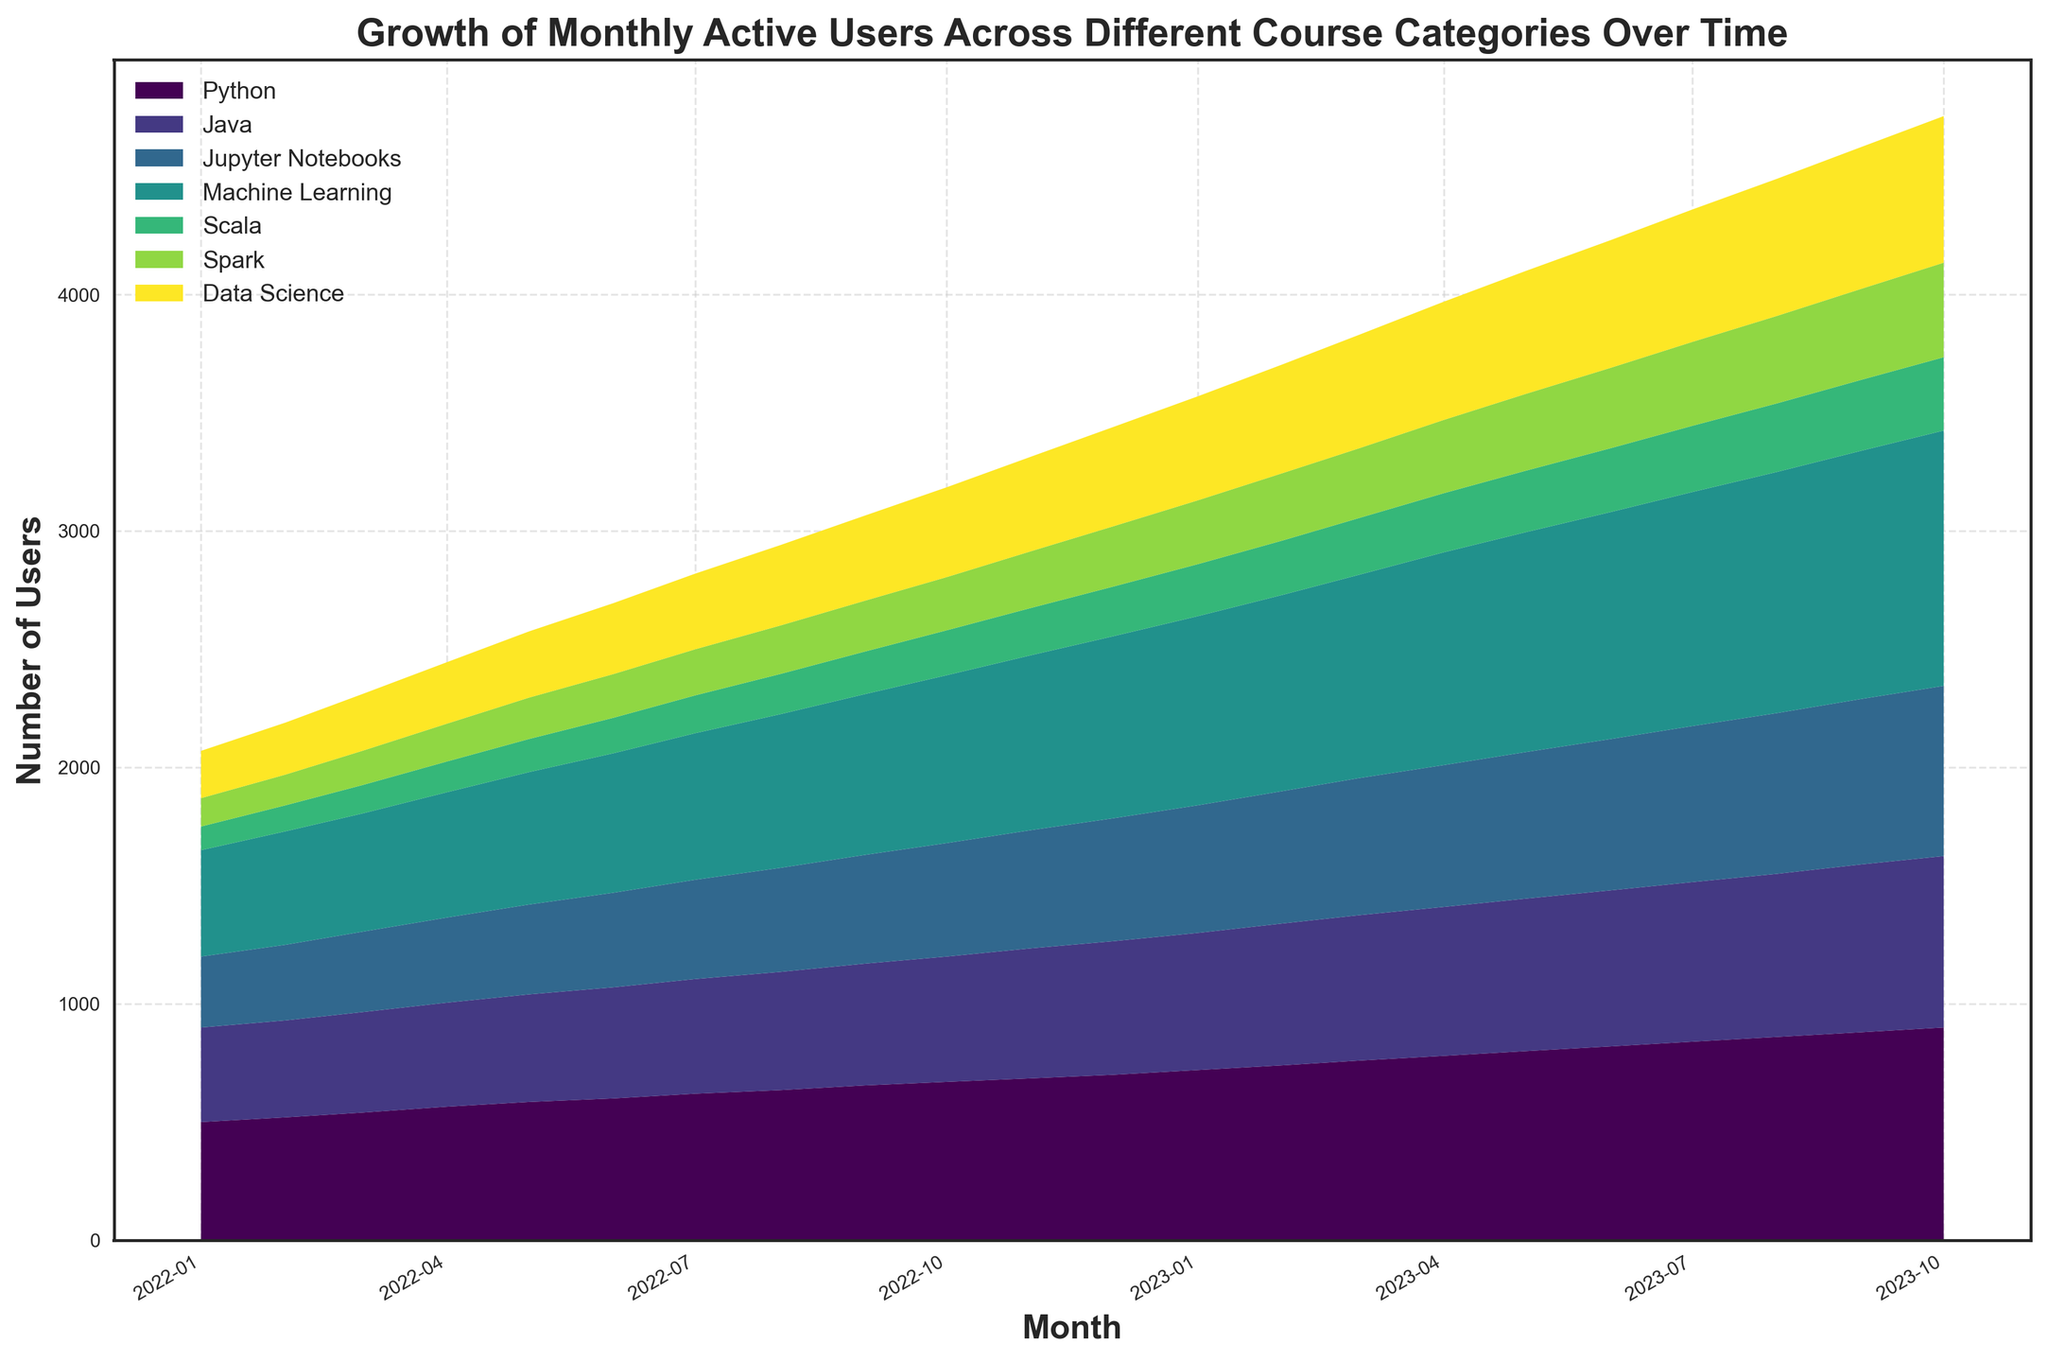What's the overall trend of active users in the Machine Learning category over time? To answer this, observe the area representing "Machine Learning." It consistently grows over time, indicating a steady increase in active users.
Answer: Steady increase Which category experienced the highest growth in monthly active users from January 2022 to October 2023? Look at the areas and their growth. "Machine Learning" has the steepest upward slope, indicating the highest growth in active users.
Answer: Machine Learning How do the user numbers for Scala and Spark compare in July 2023? Check the heights of the "Scala" and "Spark" areas in July 2023. Scala has fewer users than Spark.
Answer: Spark has more users than Scala By what factor did the number of active users in the Scala category multiply from January 2022 to October 2023? The number grew from 100 in January 2022 to 310 in October 2023. Divide 310 by 100. 310 / 100 = 3.1.
Answer: 3.1 What is the difference in the number of users between the Data Science and Java categories in September 2023? Identify the user counts for "Data Science" (600) and "Java" (710). Subtract 600 from 710. 710 - 600 = 110.
Answer: 110 In which month did Python first surpass 800 active users? Observe the "Python" area and identify the first month it exceeds 800. This happens in May 2023.
Answer: May 2023 What is the average monthly increase in active users for the Python category between January 2022 and October 2023? The user count for Python goes from 500 to 900, an increase of 400 over 22 months. Divide 400 by 22. 400 / 22 ≈ 18.18.
Answer: 18.18 How does the growth of the Jupyter Notebooks category compare to the Java category over the entire period? Both show growth, but Java has a more consistent increase. Jupyter Notebooks also increases but at a slower rate.
Answer: Java grows more consistently If you sum the total number of active users across all categories in January 2023, what is the value? Sum the users: Python (720) + Java (580) + Jupyter Notebooks (540) + Machine Learning (800) + Scala (220) + Spark (270) + Data Science (440). 720 + 580 + 540 + 800 + 220 + 270 + 440 = 3570.
Answer: 3570 